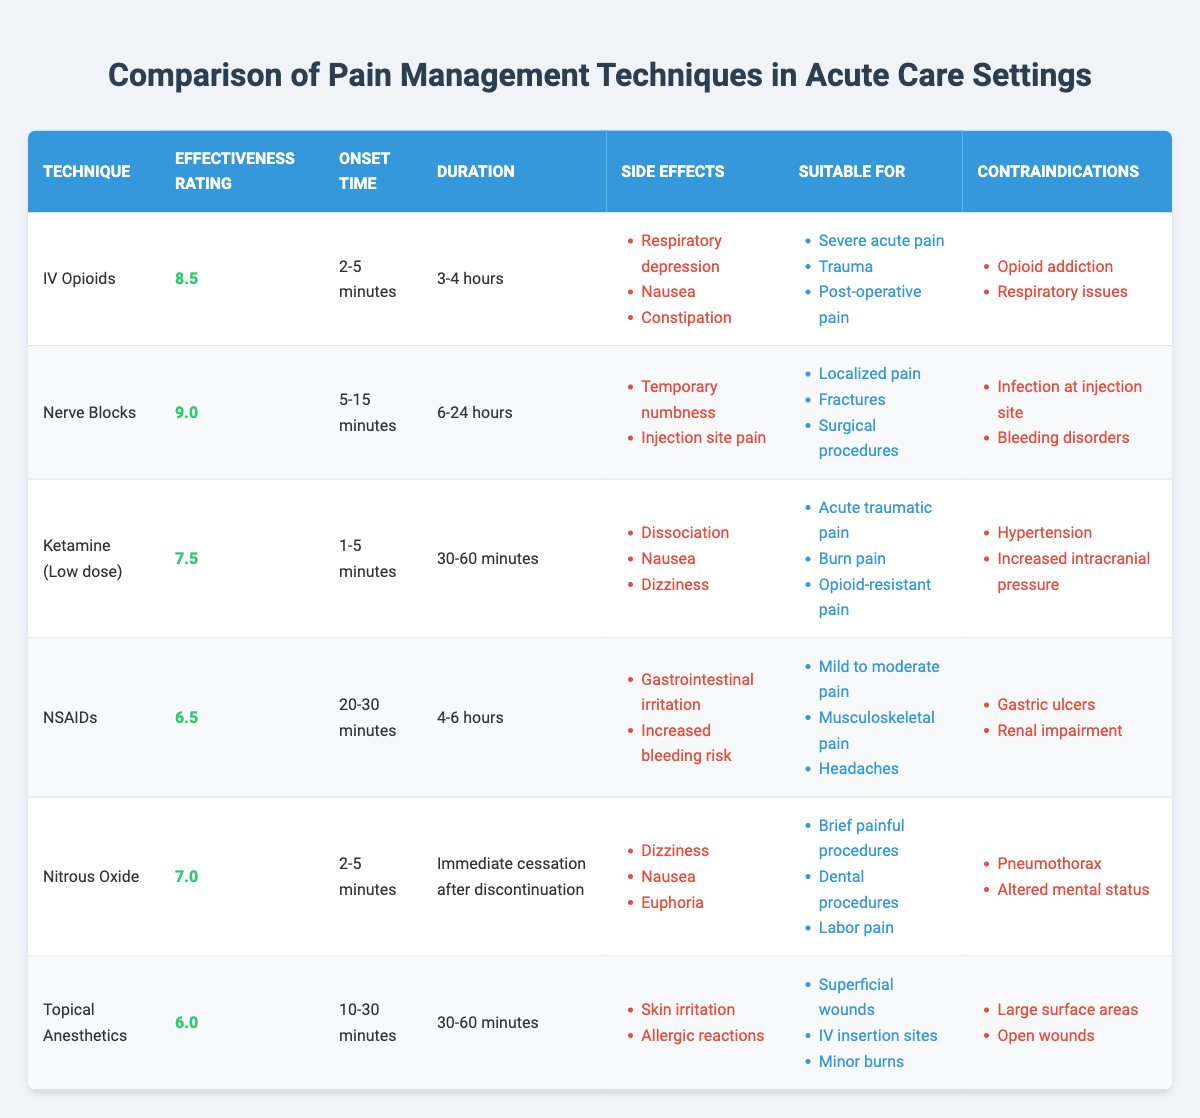What is the effectiveness rating for IV Opioids? The effectiveness rating for IV Opioids is listed in the second column of the table, which specifically states the rating as 8.5.
Answer: 8.5 Which pain management technique has the longest duration? By inspecting the duration column, Nerve Blocks shows a range of 6-24 hours, which is the longest compared to the other techniques.
Answer: Nerve Blocks Are NSAIDs suitable for treating headaches? The table shows that NSAIDs are classified under the "suitable for" category for treating headaches, confirming they can effectively address this pain.
Answer: Yes What is the average effectiveness rating of the techniques listed? To calculate the average effectiveness rating, sum up all ratings (8.5 + 9.0 + 7.5 + 6.5 + 7.0 + 6.0 = 44.5) and divide by the number of techniques (6). The average is 44.5/6 = 7.42.
Answer: 7.42 Does Ketamine have any contraindications for patients with hypertension? Looking at the contraindications for Ketamine in the table, hypertension is listed as a contraindication, which makes it unsuitable for patients with this condition.
Answer: Yes Which technique has the quickest onset time? The onset time for IV Opioids and Nitrous Oxide is both listed as 2-5 minutes, making them the techniques with the quickest onset.
Answer: IV Opioids and Nitrous Oxide What are the side effects for Nerve Blocks? The table indicates that the side effects for Nerve Blocks are temporary numbness and injection site pain, which are listed in the respective column.
Answer: Temporary numbness, injection site pain Which technique is most suitable for acute traumatic pain? The table designates Ketamine (Low dose) as suitable for acute traumatic pain as per the "suitable for" section indicating this specific application.
Answer: Ketamine (Low dose) How does the effectiveness rating of Topical Anesthetics compare to NSAIDs? The effectiveness rating for Topical Anesthetics is 6.0, while for NSAIDs it is 6.5. Since 6.5 is greater than 6.0, NSAIDs are rated higher than Topical Anesthetics.
Answer: NSAIDs are rated higher 